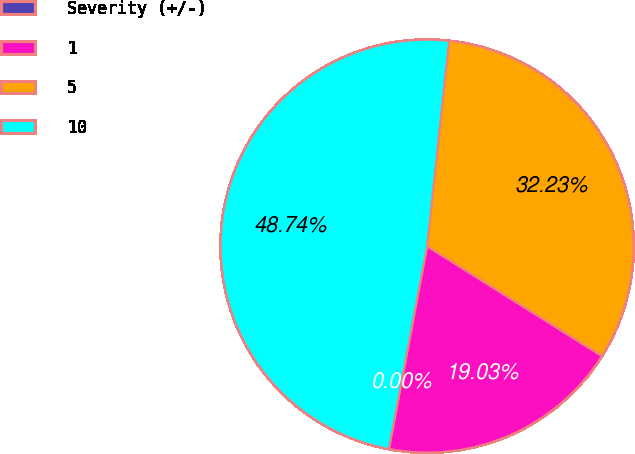Convert chart to OTSL. <chart><loc_0><loc_0><loc_500><loc_500><pie_chart><fcel>Severity (+/-)<fcel>1<fcel>5<fcel>10<nl><fcel>0.0%<fcel>19.03%<fcel>32.23%<fcel>48.74%<nl></chart> 